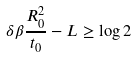Convert formula to latex. <formula><loc_0><loc_0><loc_500><loc_500>\delta \beta \frac { R _ { 0 } ^ { 2 } } { t _ { 0 } } - L \geq \log 2</formula> 